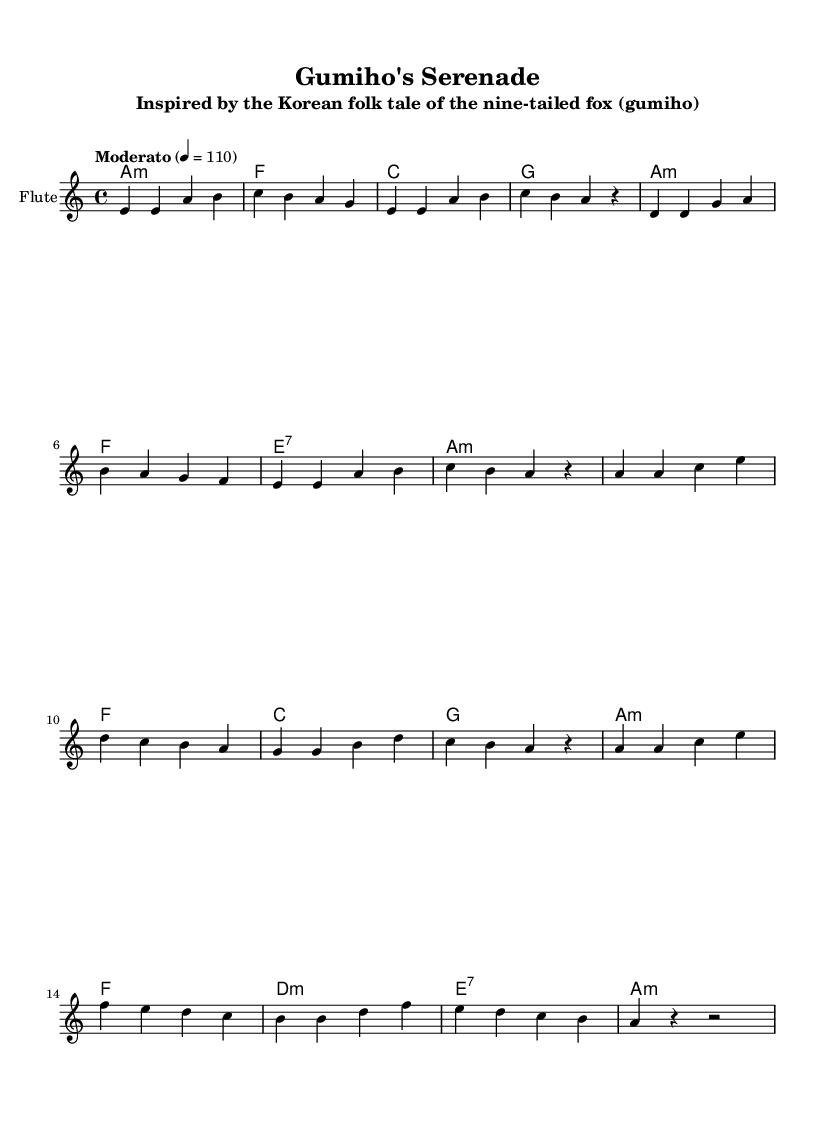What is the key signature of this music? The key signature is A minor, indicated by the absence of sharps or flats at the beginning of the staff.
Answer: A minor What is the time signature of this piece? The time signature is 4/4, shown at the beginning of the score, which signifies four beats per measure and a quarter note gets one beat.
Answer: 4/4 What is the tempo marking for this piece? The tempo marking is "Moderato," which suggests a moderate pace, indicated within the score next to the tempo directive.
Answer: Moderato How many measures are in the verse section? The verse section consists of eight measures, which can be counted from the beginning until before the chorus starts.
Answer: Eight Which instrument is featured in this score? The primary instrument featured is the Flute, as stated at the beginning of the staff, indicating the type of instrument for this arrangement.
Answer: Flute How many unique chords are present in the verse? The verse section presents four unique chords: A minor, F, C, and G, as shown in the chord names aligned with the melody for that section.
Answer: Four What is the last note in the melody? The last note in the melody is a rest, which signals the end of the phrase in the last measure of the song.
Answer: Rest 